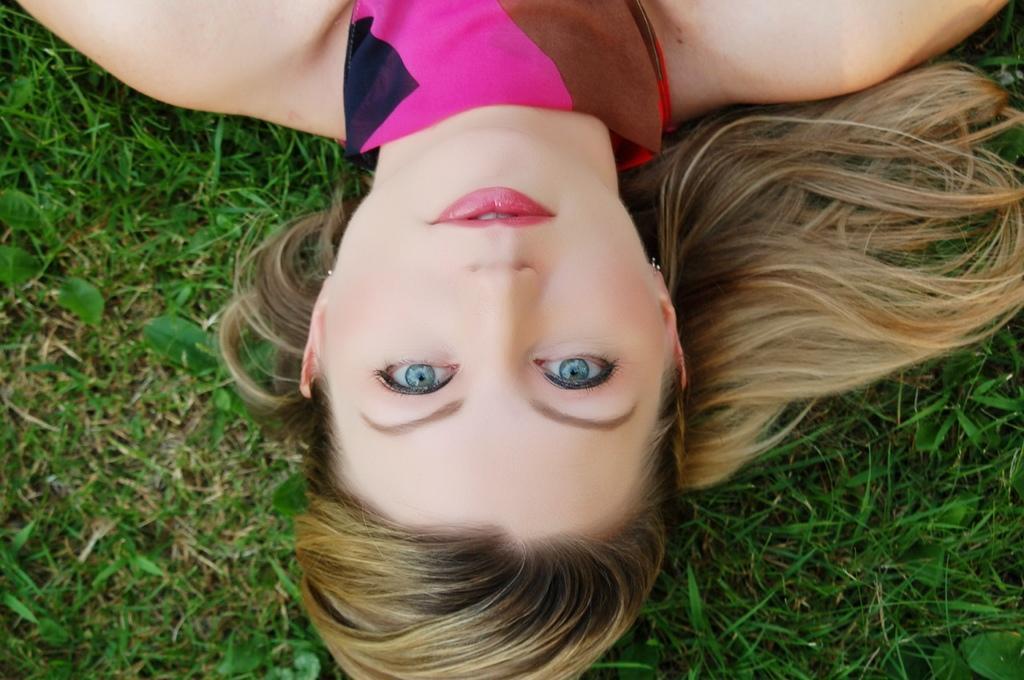Please provide a concise description of this image. There is a woman on the grass. 